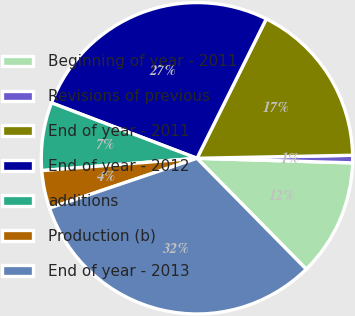Convert chart to OTSL. <chart><loc_0><loc_0><loc_500><loc_500><pie_chart><fcel>Beginning of year - 2011<fcel>Revisions of previous<fcel>End of year - 2011<fcel>End of year - 2012<fcel>additions<fcel>Production (b)<fcel>End of year - 2013<nl><fcel>12.15%<fcel>0.78%<fcel>17.35%<fcel>26.55%<fcel>7.06%<fcel>3.92%<fcel>32.2%<nl></chart> 